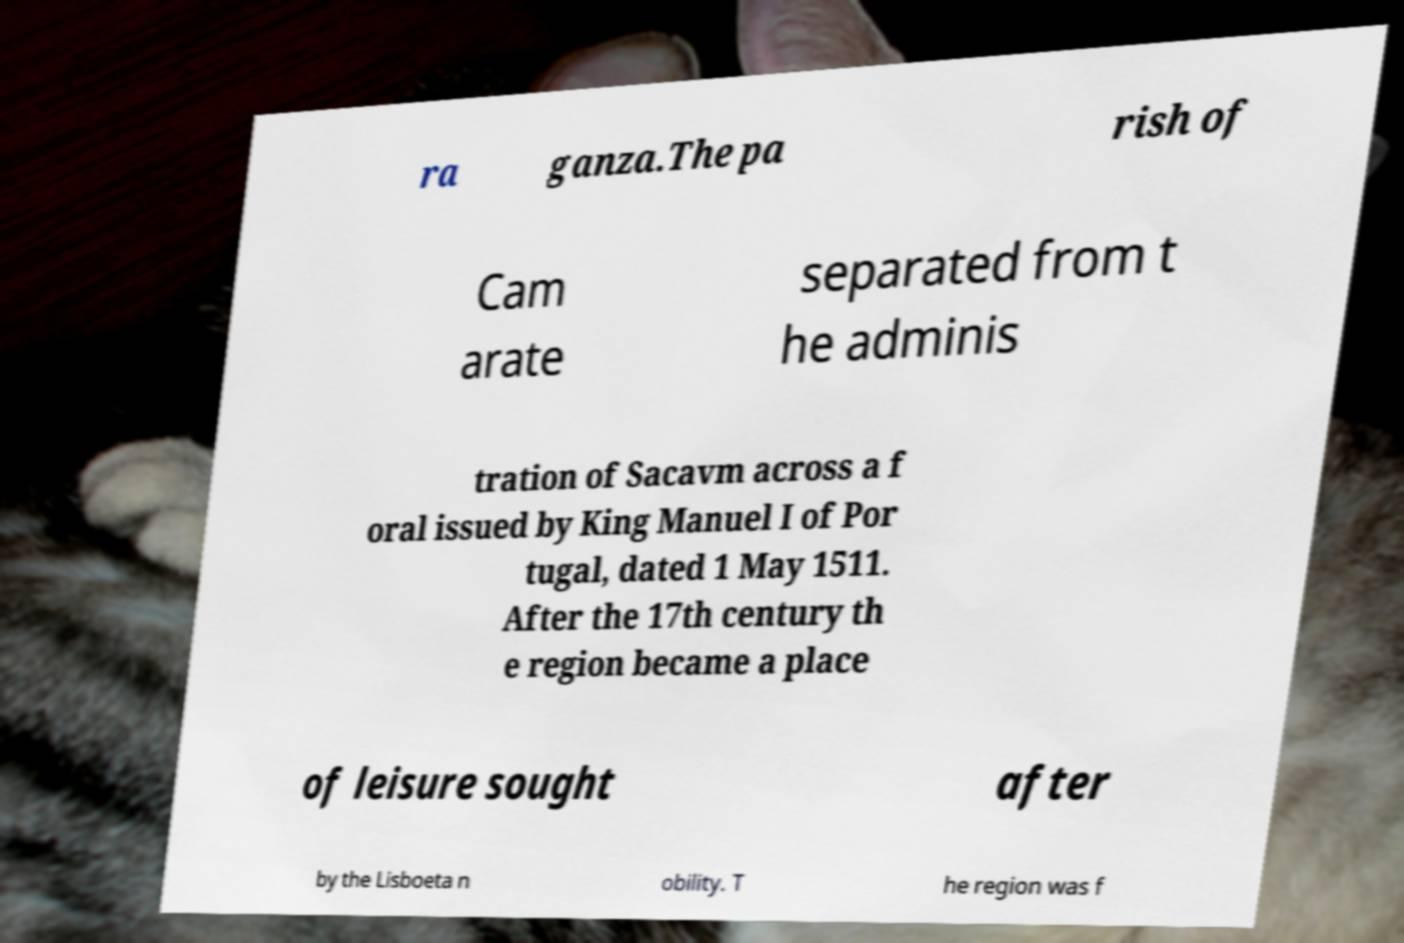Can you read and provide the text displayed in the image?This photo seems to have some interesting text. Can you extract and type it out for me? ra ganza.The pa rish of Cam arate separated from t he adminis tration of Sacavm across a f oral issued by King Manuel I of Por tugal, dated 1 May 1511. After the 17th century th e region became a place of leisure sought after by the Lisboeta n obility. T he region was f 